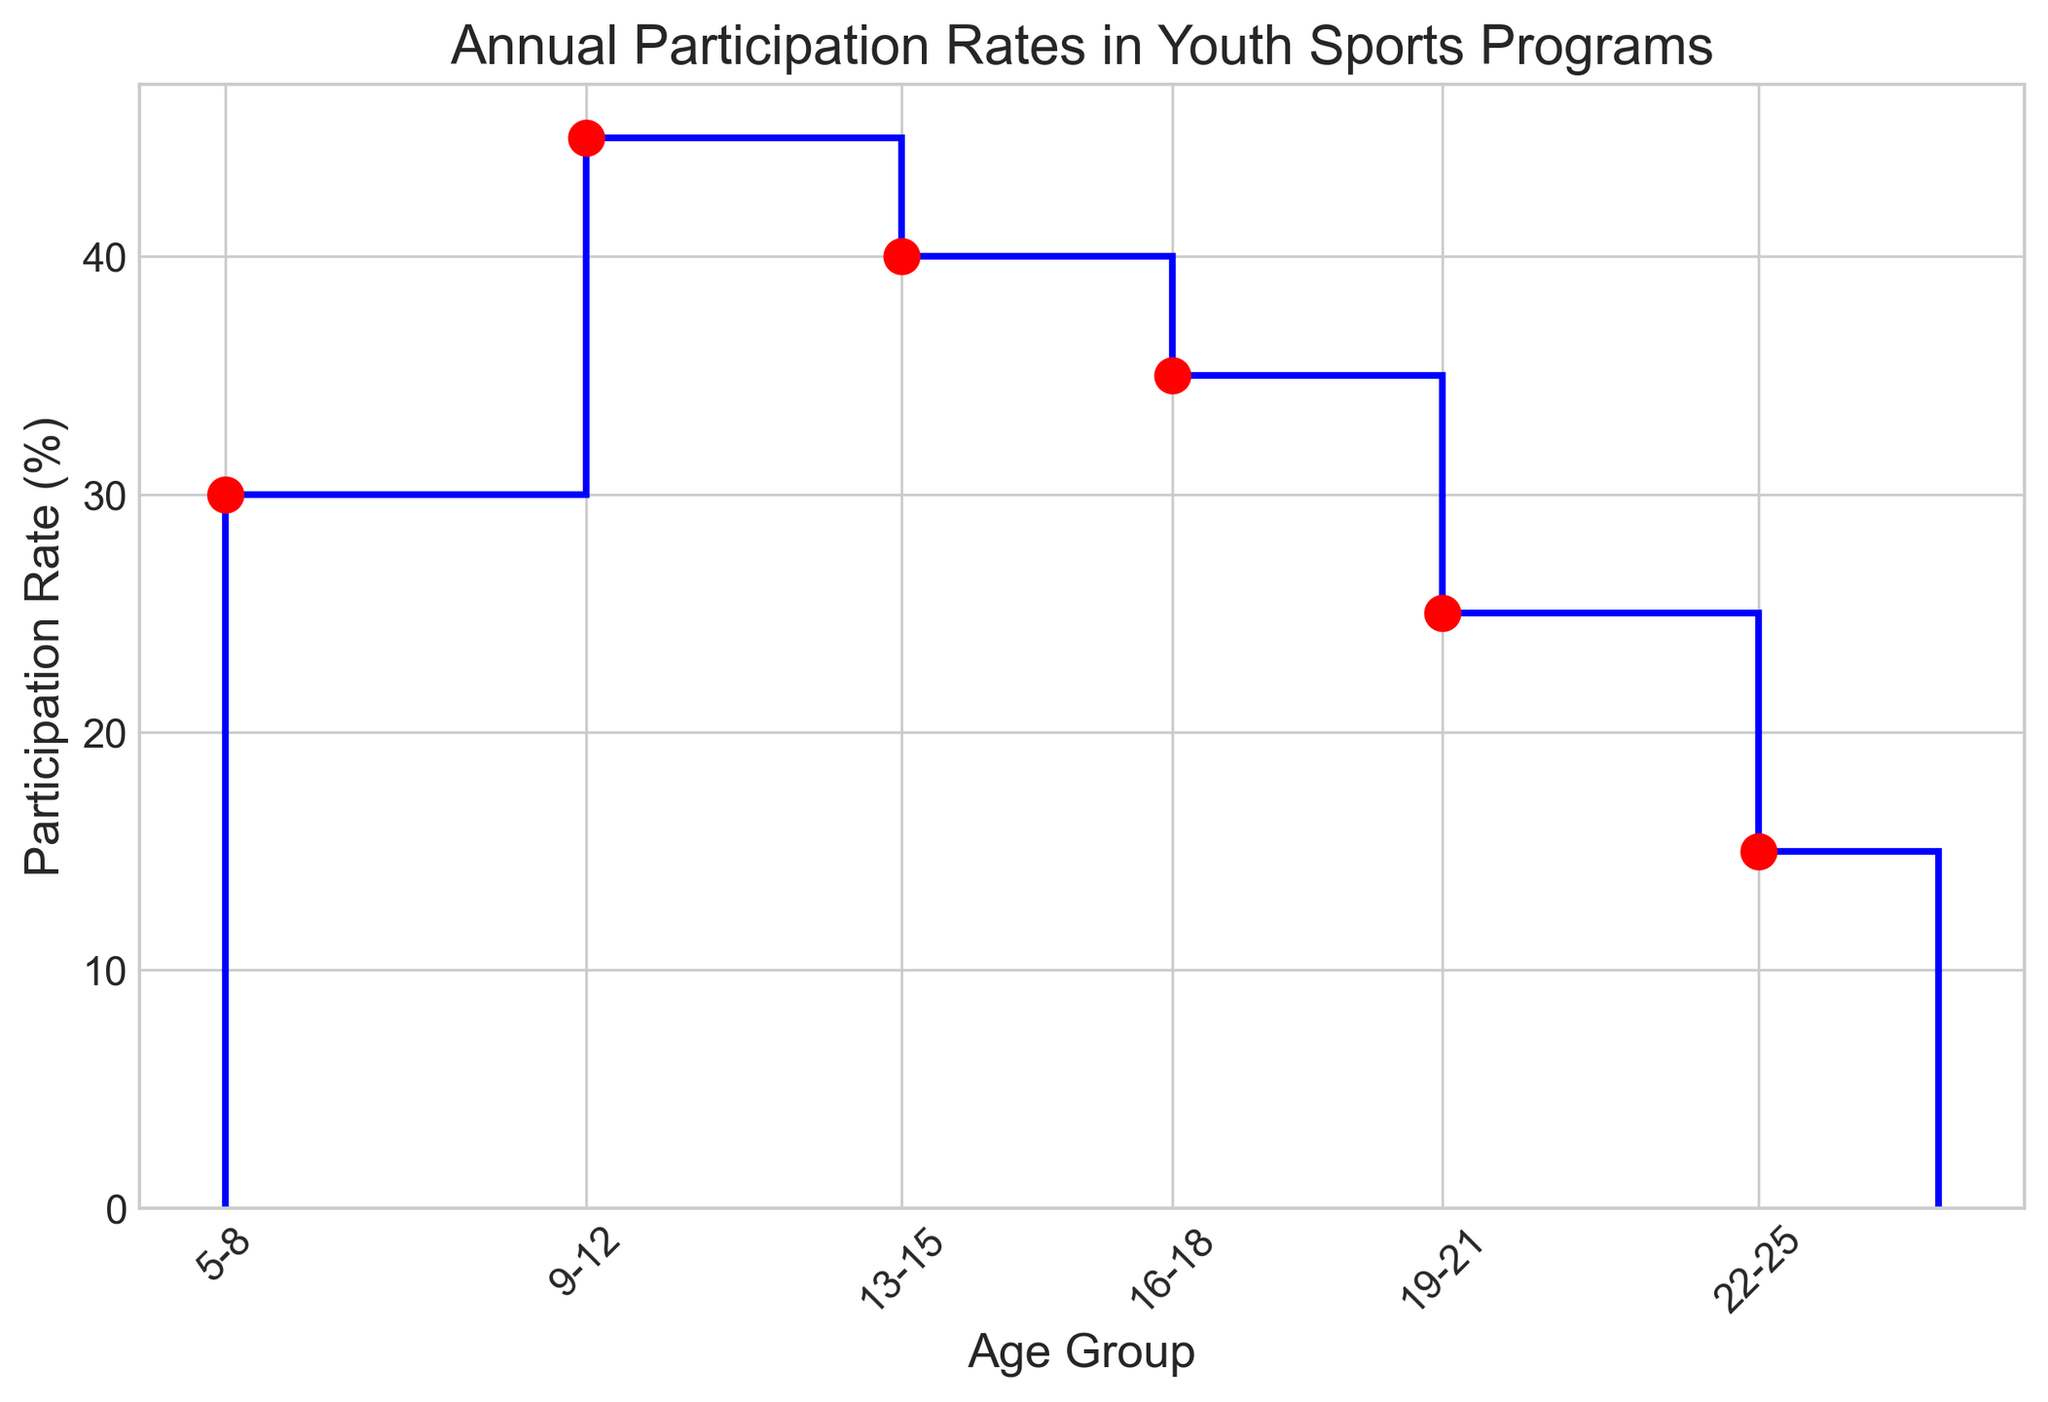What's the difference in participation rates between the youngest (5-8) and the oldest (22-25) age groups? The participation rate for the 5-8 age group is 30%, and for the 22-25 age group, it is 15%. The difference is 30% - 15% = 15%.
Answer: 15% Which age group has the highest participation rate? By looking at the heights of the stair plot steps, the 9-12 age group has the highest participation rate at 45%.
Answer: 9-12 What is the average participation rate across all age groups? Sum of participation rates: 30% + 45% + 40% + 35% + 25% + 15% = 190%. There are 6 age groups, so the average is 190% / 6 = ~31.67%.
Answer: ~31.67% Is the participation rate for the 13-15 age group greater than or less than the 16-18 age group? The participation rate for the 13-15 age group is 40%, while for the 16-18 age group, it is 35%. Therefore, it is greater.
Answer: Greater Do any two age groups have the same participation rate? By examining the plot, no two steps have the same height, indicating that all participation rates are unique.
Answer: No Which age group saw the largest drop in participation rate compared to the previous age group? The drop from 9-12 (45%) to 13-15 (40%) is 5%, from 13-15 (40%) to 16-18 (35%) is also 5%, from 16-18 (35%) to 19-21 (25%) is 10%, and from 19-21 (25%) to 22-25 (15%) is 10%. So, the largest drops are for the 16-18 to 19-21 and 19-21 to 22-25 groups.
Answer: 16-18 to 19-21 and 19-21 to 22-25 What's the median participation rate in the chart? Arrange the rates: 15%, 25%, 30%, 35%, 40%, 45%. The median is the average of the two middle values, (30% + 35%) / 2 = 32.5%.
Answer: 32.5% Are the steps on the plot higher or lower after the 18-year-old group? Looking at the x-axis labels, the steps representing age groups 19-21 and 22-25 are lower (25% and 15% respectively) than those of younger age groups.
Answer: Lower What is the visual difference between the markers and the stairs line on the plot? The markers on the plot are red circles, whereas the stairs line is a blue line.
Answer: Markers are red circles, stairs line is blue Is the participation rate for the 9-12 age group higher than the average participation rate? The average participation across all age groups is approximately 31.67%. The participation rate for the 9-12 age group is 45%, which is higher than the average.
Answer: Yes 